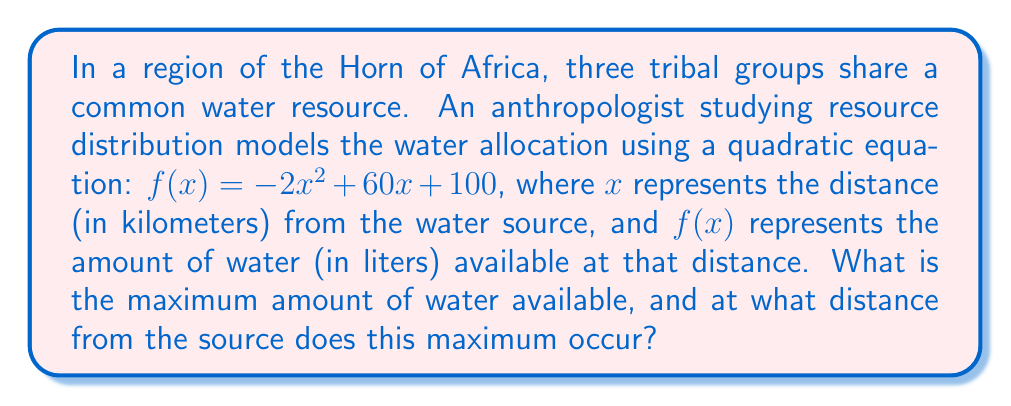Provide a solution to this math problem. To solve this problem, we need to follow these steps:

1) The given quadratic equation is in the form $f(x) = ax^2 + bx + c$, where:
   $a = -2$
   $b = 60$
   $c = 100$

2) For a quadratic function, the maximum (or minimum) occurs at the vertex of the parabola. Since $a$ is negative, this parabola opens downward and will have a maximum.

3) The x-coordinate of the vertex can be found using the formula: $x = -\frac{b}{2a}$

4) Let's calculate this:
   $$x = -\frac{60}{2(-2)} = -\frac{60}{-4} = 15$$

5) To find the maximum amount of water, we need to calculate $f(15)$:

   $$\begin{align}
   f(15) &= -2(15)^2 + 60(15) + 100 \\
   &= -2(225) + 900 + 100 \\
   &= -450 + 900 + 100 \\
   &= 550
   \end{align}$$

Therefore, the maximum amount of water available is 550 liters, occurring at a distance of 15 kilometers from the source.
Answer: The maximum amount of water available is 550 liters, occurring at a distance of 15 kilometers from the source. 